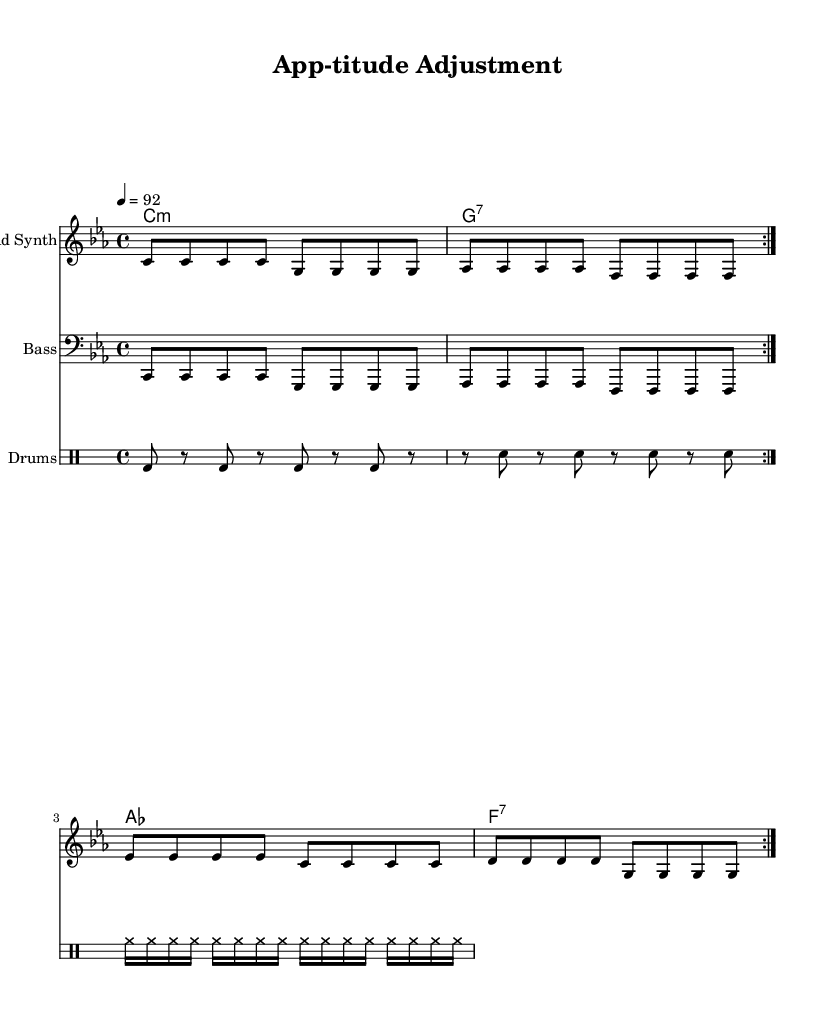What is the key signature of this music? The key signature is C minor, which has three flats (B-flat, E-flat, and A-flat). This can be determined from the clef and key signature at the beginning of the score.
Answer: C minor What is the time signature of this piece? The time signature is 4/4, indicated at the beginning of the score. This means there are four beats in each measure, and the quarter note gets one beat.
Answer: 4/4 What is the tempo marking of the piece? The tempo marking is 92 beats per minute, specified at the beginning with "4 = 92". This indicates the speed at which the music should be played.
Answer: 92 How many measures are in the melody section? The melody has a total of eight measures, as counted from the repeating section where the melody is notated with two cycles of four measures each.
Answer: Eight What instrument is labeled as "Lead Synth"? The staff labeled "Lead Synth" signifies that the melody is intended for this instrument, indicated by the instrument name above the staff.
Answer: Lead Synth What is the main theme emphasized in the lyrics? The lyrics focus on collaboration and the need for adjustments in corporate culture, which reflects a modern workplace ethos aimed at breaking down silos. The repeated phrases reinforce this theme.
Answer: Collaboration 